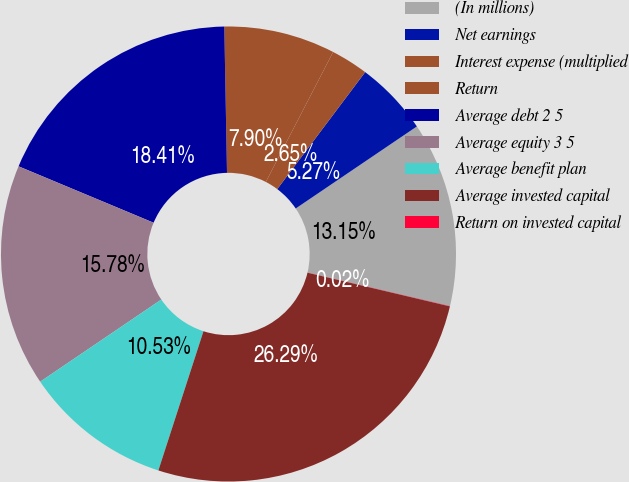Convert chart to OTSL. <chart><loc_0><loc_0><loc_500><loc_500><pie_chart><fcel>(In millions)<fcel>Net earnings<fcel>Interest expense (multiplied<fcel>Return<fcel>Average debt 2 5<fcel>Average equity 3 5<fcel>Average benefit plan<fcel>Average invested capital<fcel>Return on invested capital<nl><fcel>13.15%<fcel>5.27%<fcel>2.65%<fcel>7.9%<fcel>18.41%<fcel>15.78%<fcel>10.53%<fcel>26.29%<fcel>0.02%<nl></chart> 